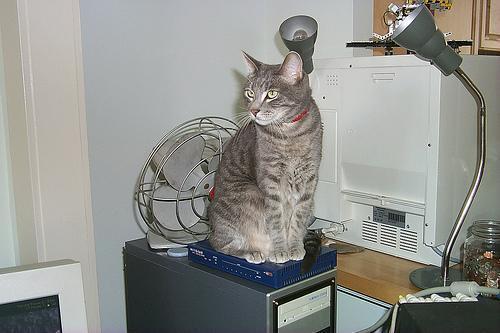How many cats are in the photo?
Give a very brief answer. 1. How many lamps are in the photo?
Give a very brief answer. 2. 